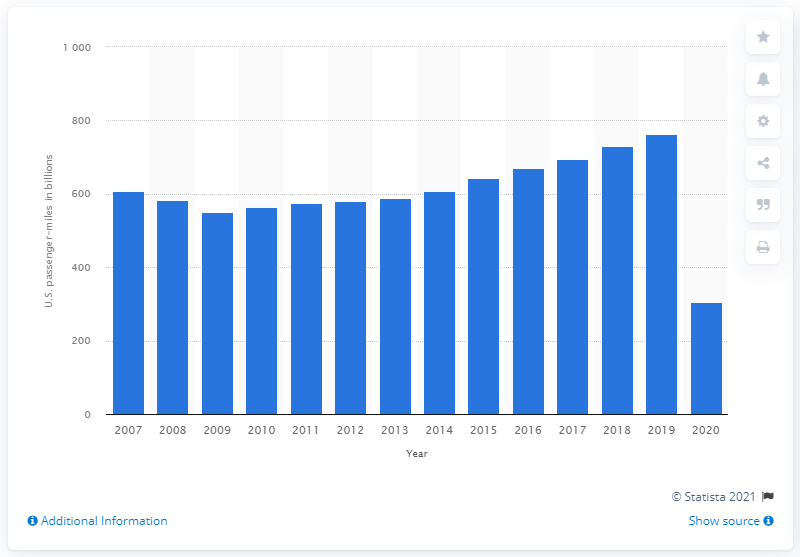Outline some significant characteristics in this image. In 2020, U.S. air passengers collectively traveled a total of 306,220 miles by plane. 